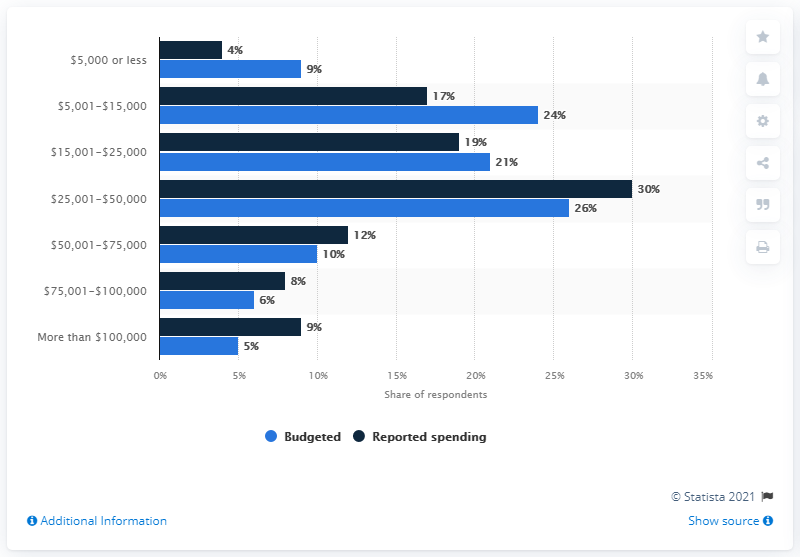Mention a couple of crucial points in this snapshot. According to the reported spending, approximately 9% of the total spending was between $5,000 or less. The difference between budgeted and reported spending is most significant when the actual spending falls within the range of $5,001-$15,000. 